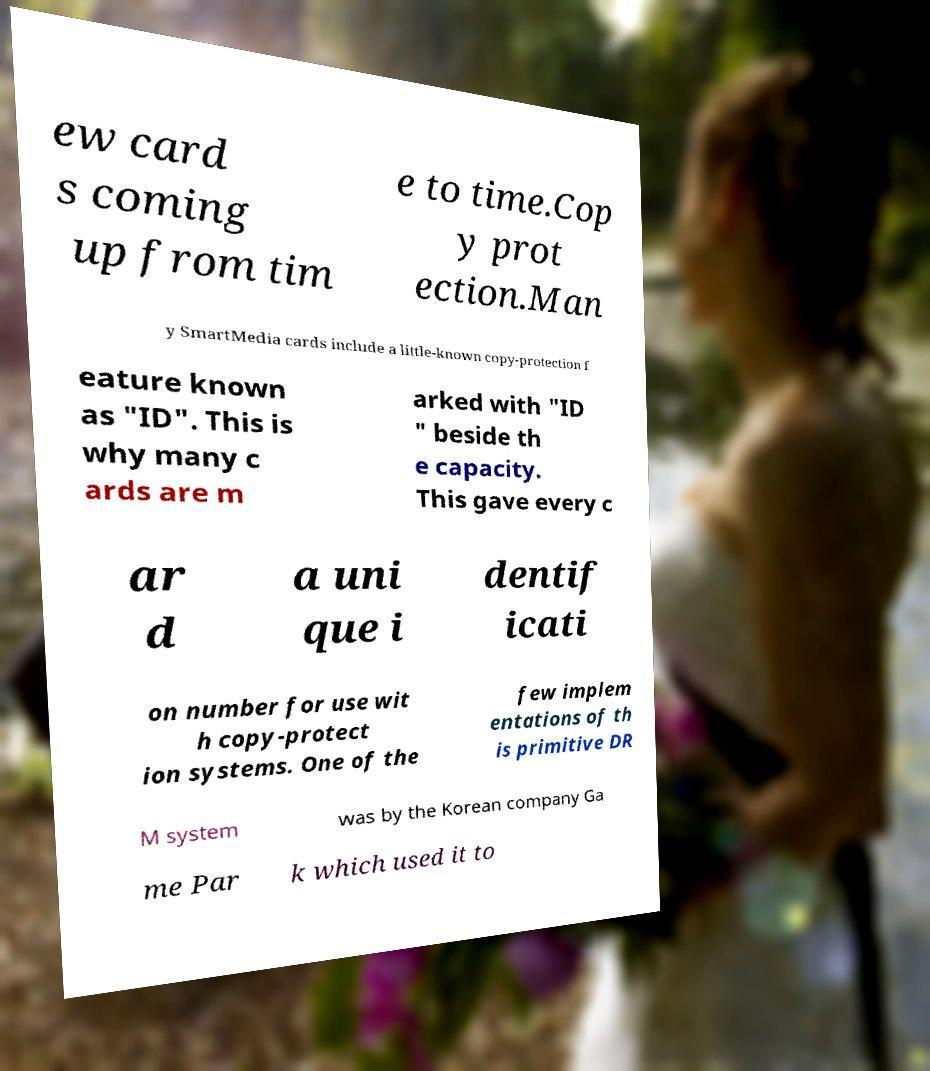Could you extract and type out the text from this image? ew card s coming up from tim e to time.Cop y prot ection.Man y SmartMedia cards include a little-known copy-protection f eature known as "ID". This is why many c ards are m arked with "ID " beside th e capacity. This gave every c ar d a uni que i dentif icati on number for use wit h copy-protect ion systems. One of the few implem entations of th is primitive DR M system was by the Korean company Ga me Par k which used it to 